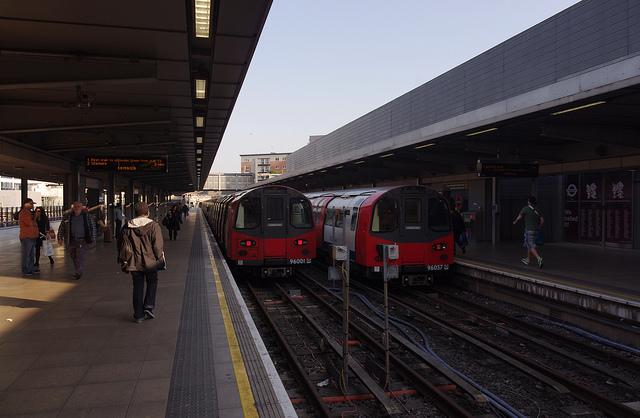What information does such an electronic billboard depict in this scenario?

Choices:
A) train
B) weather
C) stock market
D) politics train 